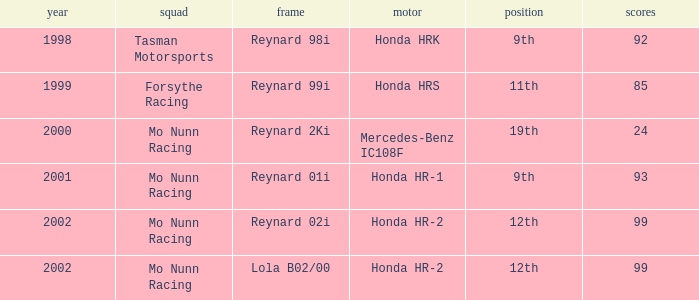What is the rank of the reynard 2ki chassis before 2002? 19th. 